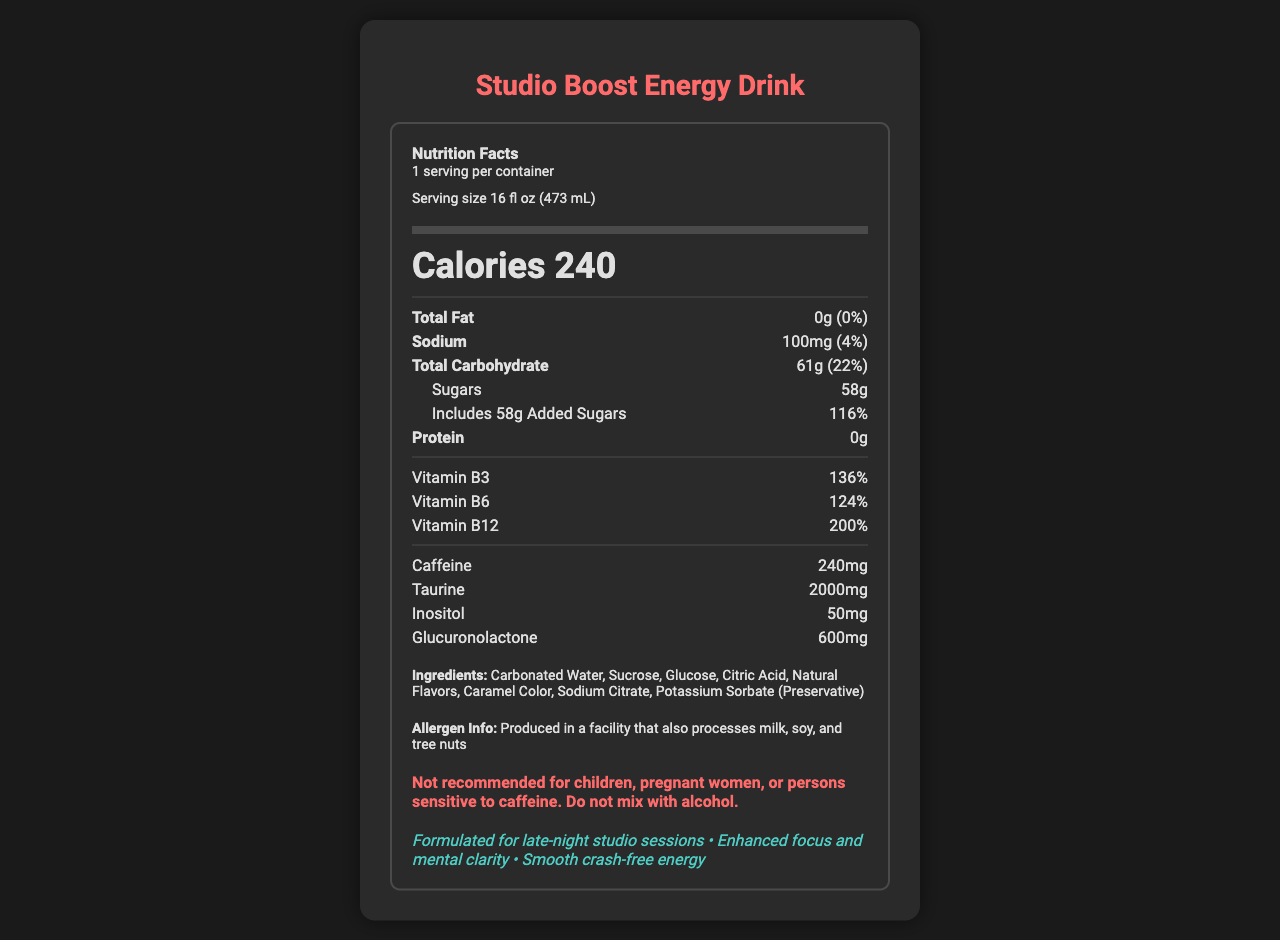what is the serving size of the "Studio Boost Energy Drink"? The serving size is explicitly listed as "16 fl oz (473 mL)" in the document.
Answer: 16 fl oz (473 mL) how many calories are in one serving of the energy drink? The document mentions that there are 240 calories per serving of the energy drink.
Answer: 240 how much sodium is in one serving? The sodium content per serving is listed as "100mg" in the document.
Answer: 100mg what percentage of the daily value does the total carbohydrate contribute? The total carbohydrate percentage of daily value is mentioned as "22%" in the document.
Answer: 22% how many grams of sugars does the energy drink contain? The document states that the energy drink contains "58g" of sugars.
Answer: 58g which vitamin has the highest daily value percentage? A. Vitamin B3 B. Vitamin B6 C. Vitamin B12 The document lists the daily value percentages as Vitamin B3: 136%, Vitamin B6: 124%, and Vitamin B12: 200%. The highest is Vitamin B12 with 200%.
Answer: C. Vitamin B12 how many servings are there in one container? The document mentions that there is "1 serving per container."
Answer: 1 what are some of the other ingredients listed in the energy drink? A. Carbonated Water, Sucrose, Glucose B. Milk, Soy, Tree Nuts C. Glucuronolactone, Taurine, Inositol The document lists "Carbonated Water, Sucrose, Glucose" under the other ingredients section.
Answer: A. Carbonated Water, Sucrose, Glucose does this drink contain any protein? The document explicitly states that the protein content is "0g".
Answer: No is the energy drink suitable for children? The document has a warning stating it is "Not recommended for children".
Answer: No summarize the main nutritional information provided for the energy drink. The document provides detailed nutritional information, including calories, macronutrients, and specific vitamins and active ingredients. It also includes warnings and allergen information.
Answer: The "Studio Boost Energy Drink" has 240 calories per 16 fl oz serving, with 0g total fat, 100mg sodium, 61g total carbohydrates (including 58g sugars and 58g added sugars), and 0g protein. It contains vitamins B3, B6, and B12 with high daily value percentages, and includes caffeine, taurine, inositol, and glucuronolactone as additional active ingredients. The drink is not recommended for children, pregnant women, or individuals sensitive to caffeine. how does this energy drink benefit late-night studio sessions according to the marketing claims? According to the marketing claims listed in the document, the energy drink is formulated for late-night studio sessions to enhance focus and mental clarity and provide smooth crash-free energy.
Answer: Enhanced focus and mental clarity, smooth crash-free energy how much caffeine does the energy drink contain? The document lists "240mg" of caffeine in the energy drink.
Answer: 240mg what is the percentage of daily value for added sugars included in this drink? The document states that the added sugars contribute "116%" of the daily value.
Answer: 116% what is glucuronolactone and how much is in the energy drink? The document lists "glucuronolactone" as one of its contents, and the amount is specified to be "600mg".
Answer: 600mg who should avoid consuming this energy drink? The warning in the document states it is "Not recommended for children, pregnant women, or persons sensitive to caffeine."
Answer: Children, pregnant women, persons sensitive to caffeine where is the energy drink produced? The document does not provide information about where the energy drink is produced.
Answer: Cannot be determined 